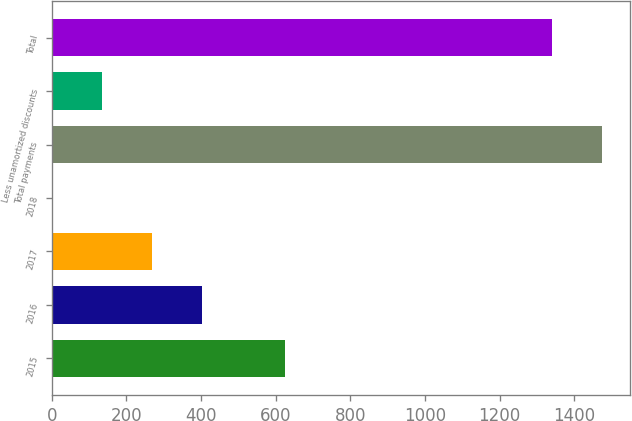<chart> <loc_0><loc_0><loc_500><loc_500><bar_chart><fcel>2015<fcel>2016<fcel>2017<fcel>2018<fcel>Total payments<fcel>Less unamortized discounts<fcel>Total<nl><fcel>623.7<fcel>403.77<fcel>269.58<fcel>1.2<fcel>1474.19<fcel>135.39<fcel>1340<nl></chart> 